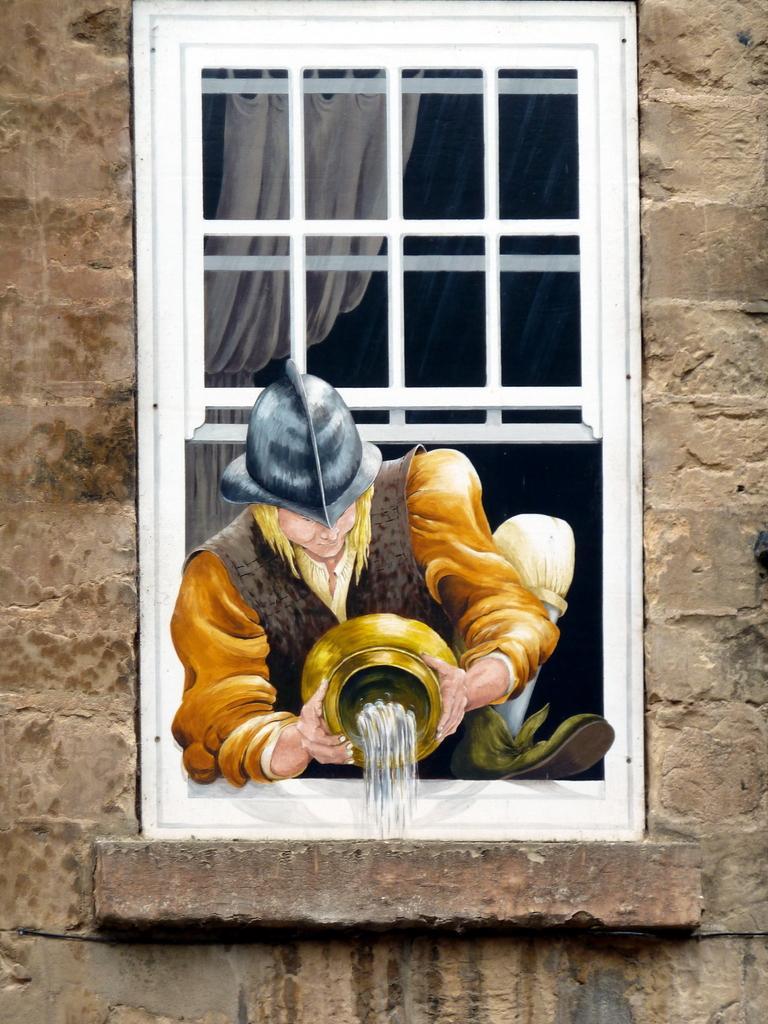Describe this image in one or two sentences. This image looks like an edited photo in which I can see a person is holding a pot in hand and I can see a window, curtain and a building wall. This image is taken, maybe during a day. 